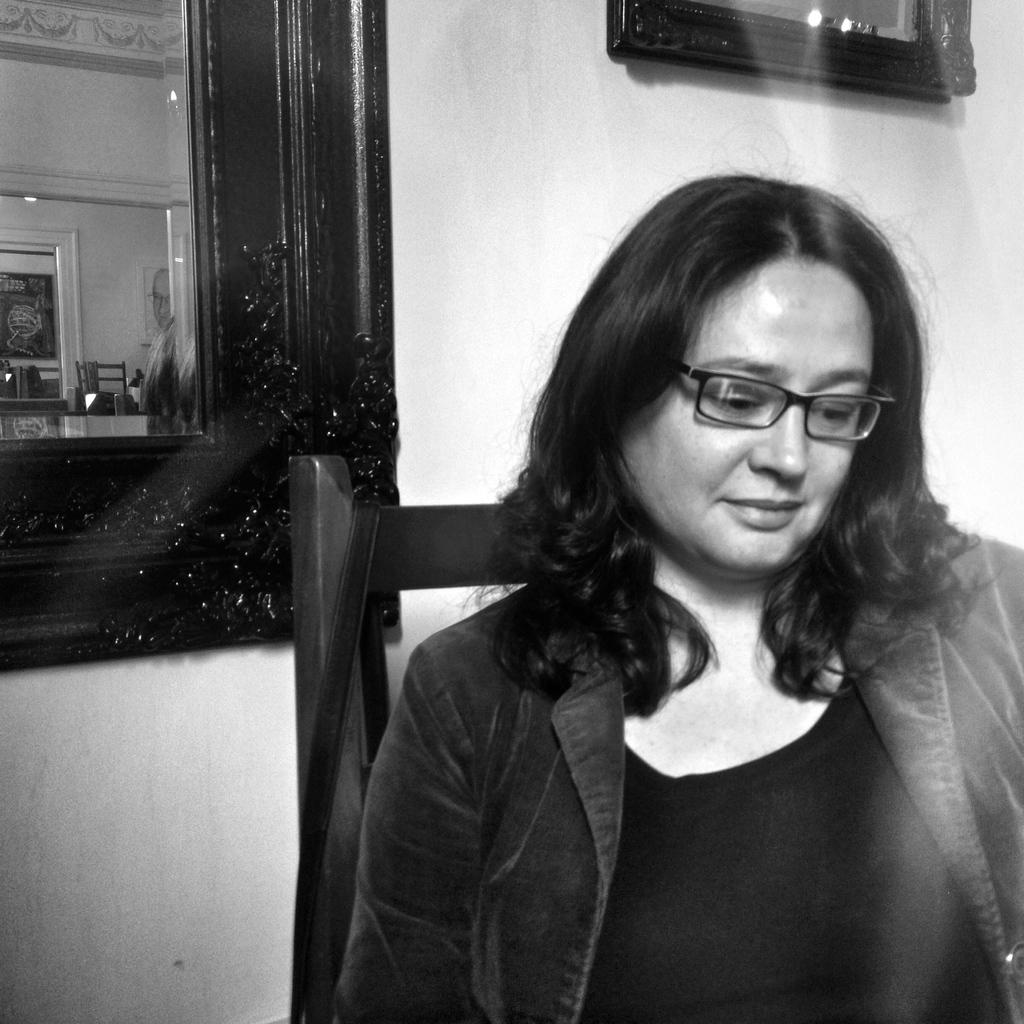What is the color scheme of the image? The image is black and white. What is the woman in the image doing? The woman is sitting on a chair in the image. Can you describe the background of the image? There is a mirror and a frame attached to the wall in the background of the image. How does the earthquake affect the woman's position in the image? There is no earthquake present in the image, so it cannot affect the woman's position. What grade does the woman receive for her performance in the image? There is no indication of a performance or grading system in the image, so it is not possible to determine a grade. 